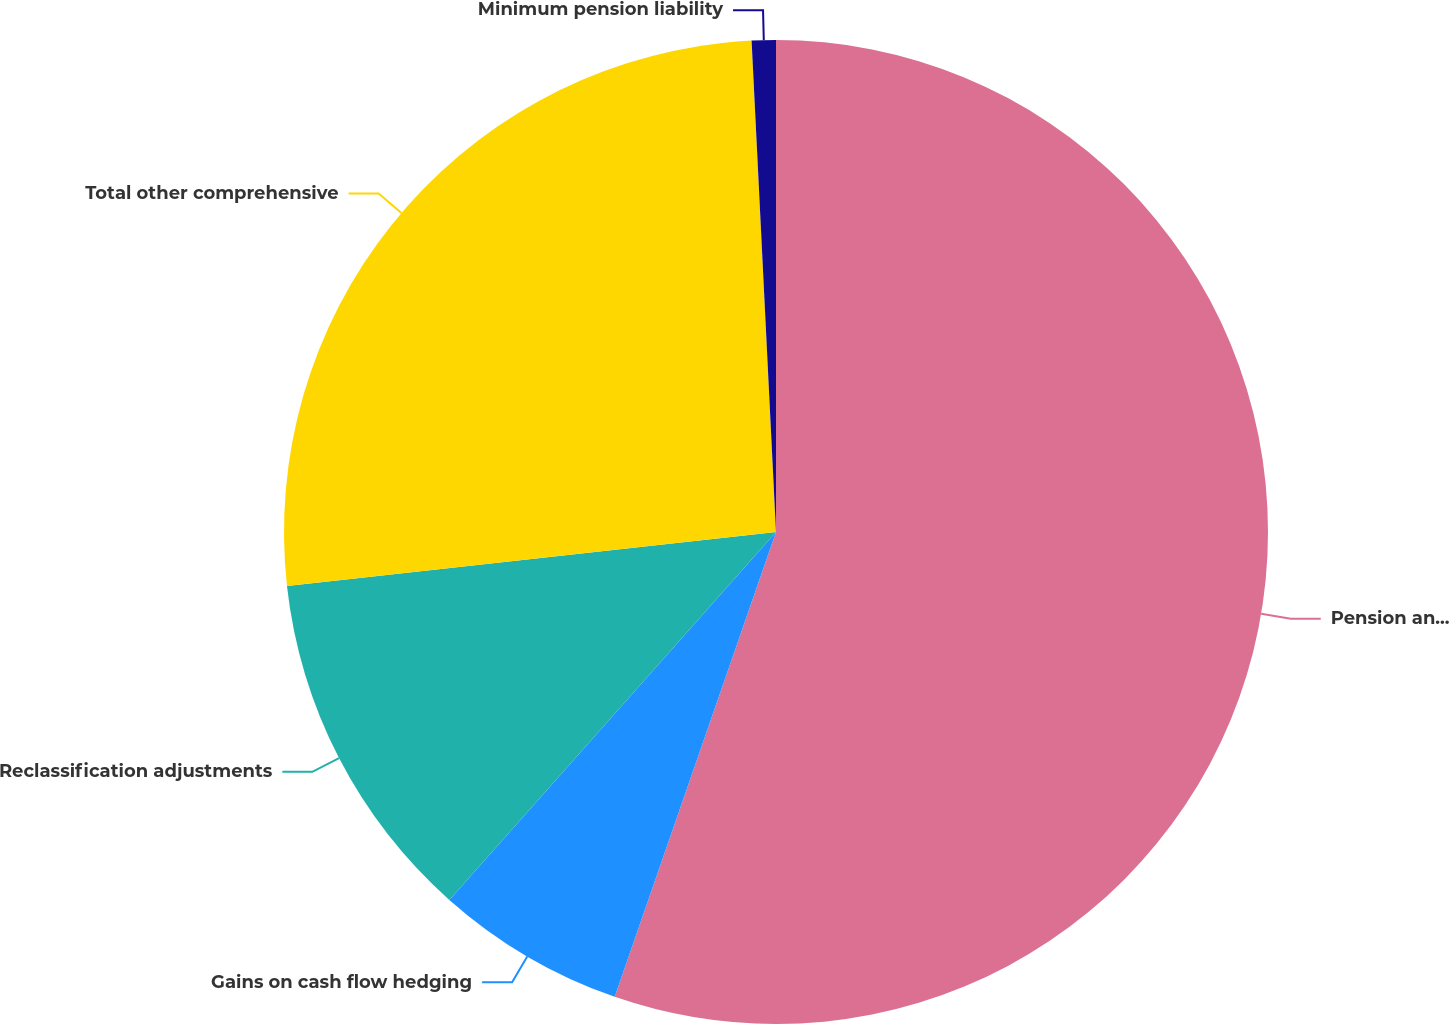Convert chart. <chart><loc_0><loc_0><loc_500><loc_500><pie_chart><fcel>Pension and post-retirement<fcel>Gains on cash flow hedging<fcel>Reclassification adjustments<fcel>Total other comprehensive<fcel>Minimum pension liability<nl><fcel>55.31%<fcel>6.24%<fcel>11.69%<fcel>25.96%<fcel>0.79%<nl></chart> 